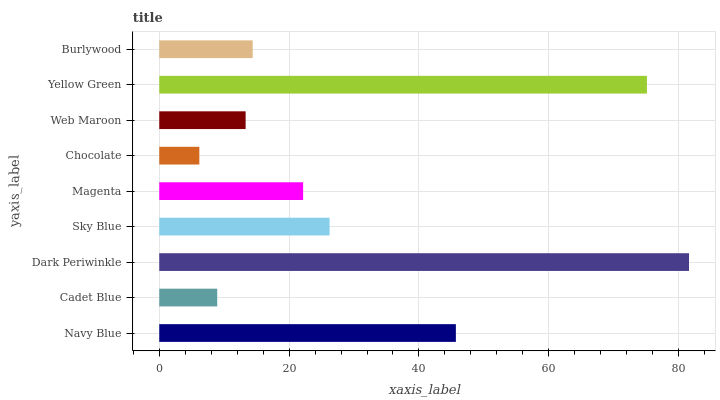Is Chocolate the minimum?
Answer yes or no. Yes. Is Dark Periwinkle the maximum?
Answer yes or no. Yes. Is Cadet Blue the minimum?
Answer yes or no. No. Is Cadet Blue the maximum?
Answer yes or no. No. Is Navy Blue greater than Cadet Blue?
Answer yes or no. Yes. Is Cadet Blue less than Navy Blue?
Answer yes or no. Yes. Is Cadet Blue greater than Navy Blue?
Answer yes or no. No. Is Navy Blue less than Cadet Blue?
Answer yes or no. No. Is Magenta the high median?
Answer yes or no. Yes. Is Magenta the low median?
Answer yes or no. Yes. Is Yellow Green the high median?
Answer yes or no. No. Is Chocolate the low median?
Answer yes or no. No. 